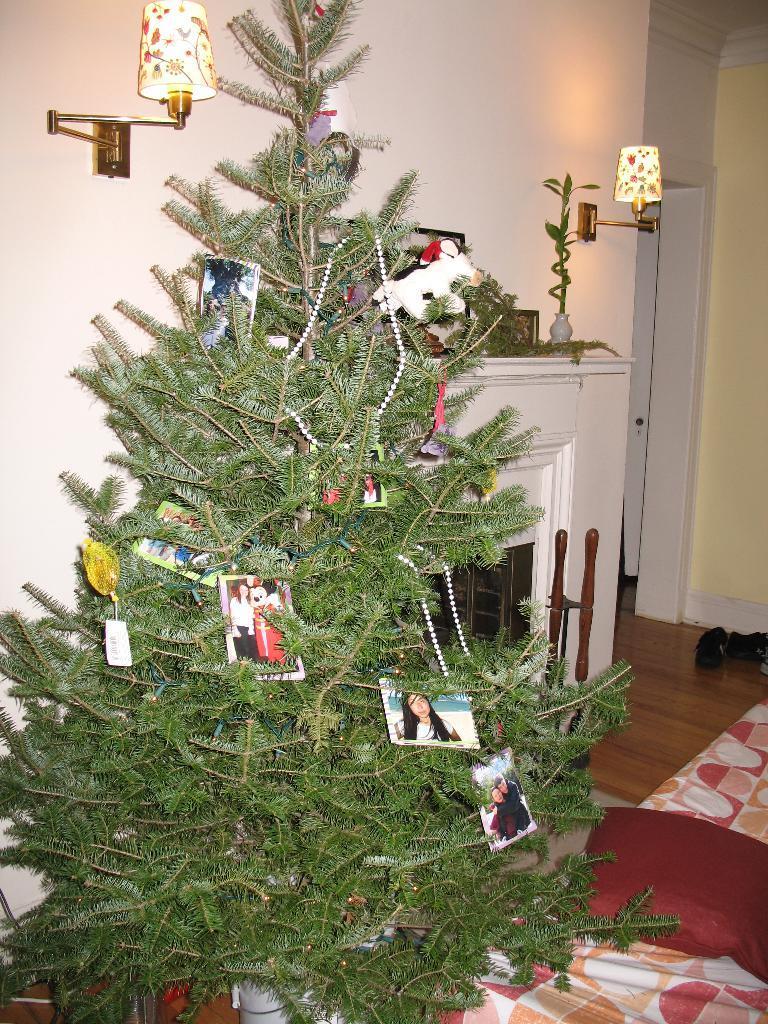Can you describe this image briefly? In this picture I can see a tree decorated with pictures, chains and some other items, there is a fireplace, there is a blanket and a pillow, there is a flower vase, there are lamps, and in the background there is a wall. 